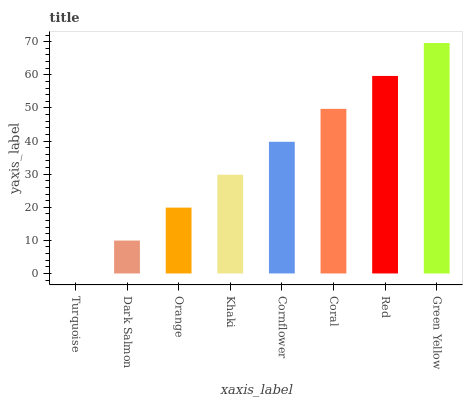Is Dark Salmon the minimum?
Answer yes or no. No. Is Dark Salmon the maximum?
Answer yes or no. No. Is Dark Salmon greater than Turquoise?
Answer yes or no. Yes. Is Turquoise less than Dark Salmon?
Answer yes or no. Yes. Is Turquoise greater than Dark Salmon?
Answer yes or no. No. Is Dark Salmon less than Turquoise?
Answer yes or no. No. Is Cornflower the high median?
Answer yes or no. Yes. Is Khaki the low median?
Answer yes or no. Yes. Is Green Yellow the high median?
Answer yes or no. No. Is Orange the low median?
Answer yes or no. No. 